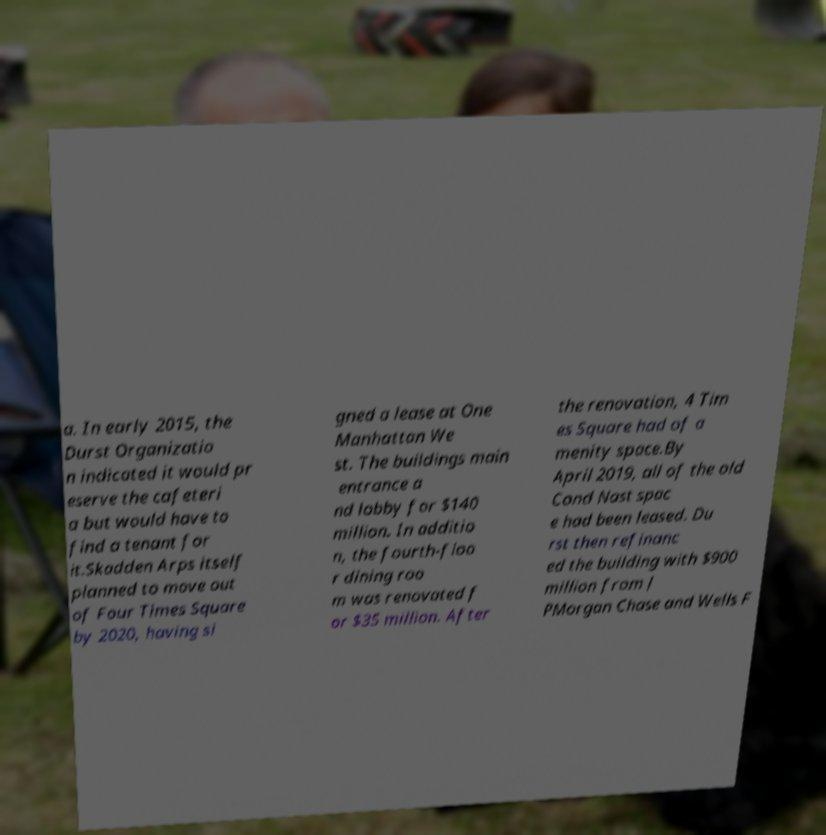Could you assist in decoding the text presented in this image and type it out clearly? a. In early 2015, the Durst Organizatio n indicated it would pr eserve the cafeteri a but would have to find a tenant for it.Skadden Arps itself planned to move out of Four Times Square by 2020, having si gned a lease at One Manhattan We st. The buildings main entrance a nd lobby for $140 million. In additio n, the fourth-floo r dining roo m was renovated f or $35 million. After the renovation, 4 Tim es Square had of a menity space.By April 2019, all of the old Cond Nast spac e had been leased. Du rst then refinanc ed the building with $900 million from J PMorgan Chase and Wells F 